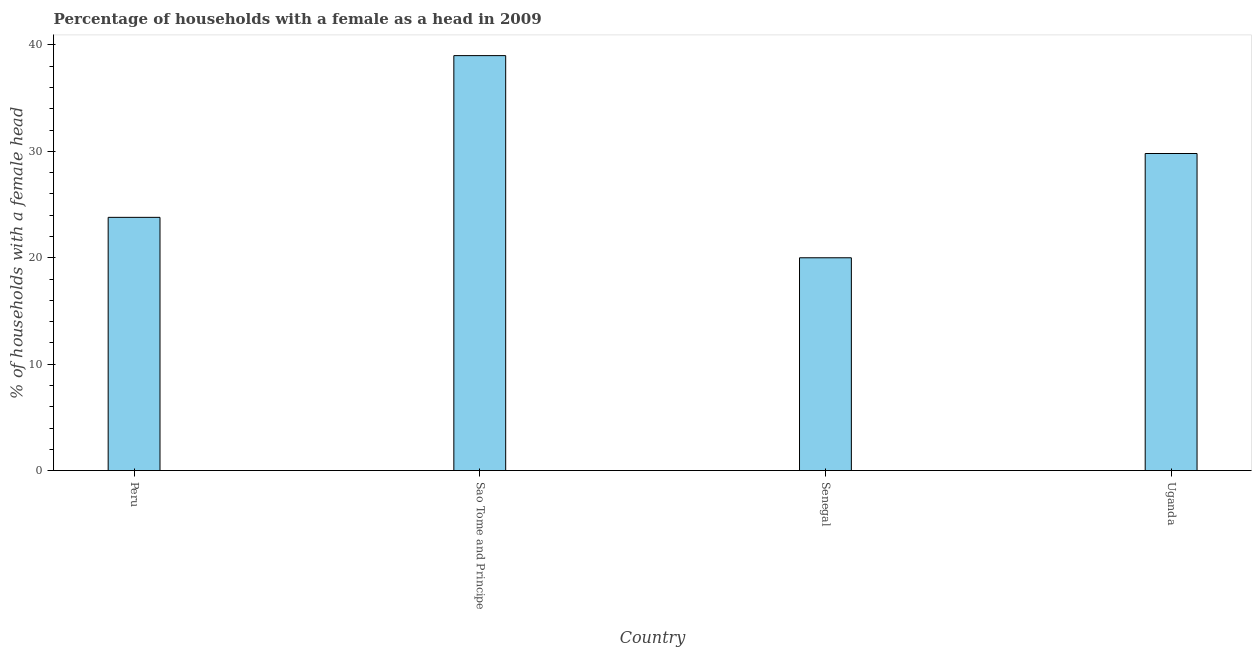Does the graph contain any zero values?
Your answer should be very brief. No. What is the title of the graph?
Ensure brevity in your answer.  Percentage of households with a female as a head in 2009. What is the label or title of the Y-axis?
Give a very brief answer. % of households with a female head. What is the number of female supervised households in Peru?
Ensure brevity in your answer.  23.8. Across all countries, what is the maximum number of female supervised households?
Make the answer very short. 39. In which country was the number of female supervised households maximum?
Offer a very short reply. Sao Tome and Principe. In which country was the number of female supervised households minimum?
Your response must be concise. Senegal. What is the sum of the number of female supervised households?
Provide a succinct answer. 112.6. What is the difference between the number of female supervised households in Peru and Sao Tome and Principe?
Offer a terse response. -15.2. What is the average number of female supervised households per country?
Ensure brevity in your answer.  28.15. What is the median number of female supervised households?
Offer a very short reply. 26.8. In how many countries, is the number of female supervised households greater than 2 %?
Offer a terse response. 4. What is the ratio of the number of female supervised households in Peru to that in Uganda?
Offer a very short reply. 0.8. Is the sum of the number of female supervised households in Peru and Uganda greater than the maximum number of female supervised households across all countries?
Keep it short and to the point. Yes. What is the difference between the highest and the lowest number of female supervised households?
Your response must be concise. 19. Are all the bars in the graph horizontal?
Provide a short and direct response. No. How many countries are there in the graph?
Offer a very short reply. 4. What is the % of households with a female head in Peru?
Your response must be concise. 23.8. What is the % of households with a female head of Sao Tome and Principe?
Make the answer very short. 39. What is the % of households with a female head in Uganda?
Offer a terse response. 29.8. What is the difference between the % of households with a female head in Peru and Sao Tome and Principe?
Provide a succinct answer. -15.2. What is the difference between the % of households with a female head in Peru and Senegal?
Provide a succinct answer. 3.8. What is the difference between the % of households with a female head in Peru and Uganda?
Make the answer very short. -6. What is the difference between the % of households with a female head in Sao Tome and Principe and Senegal?
Provide a succinct answer. 19. What is the ratio of the % of households with a female head in Peru to that in Sao Tome and Principe?
Keep it short and to the point. 0.61. What is the ratio of the % of households with a female head in Peru to that in Senegal?
Provide a short and direct response. 1.19. What is the ratio of the % of households with a female head in Peru to that in Uganda?
Ensure brevity in your answer.  0.8. What is the ratio of the % of households with a female head in Sao Tome and Principe to that in Senegal?
Offer a very short reply. 1.95. What is the ratio of the % of households with a female head in Sao Tome and Principe to that in Uganda?
Offer a very short reply. 1.31. What is the ratio of the % of households with a female head in Senegal to that in Uganda?
Your response must be concise. 0.67. 